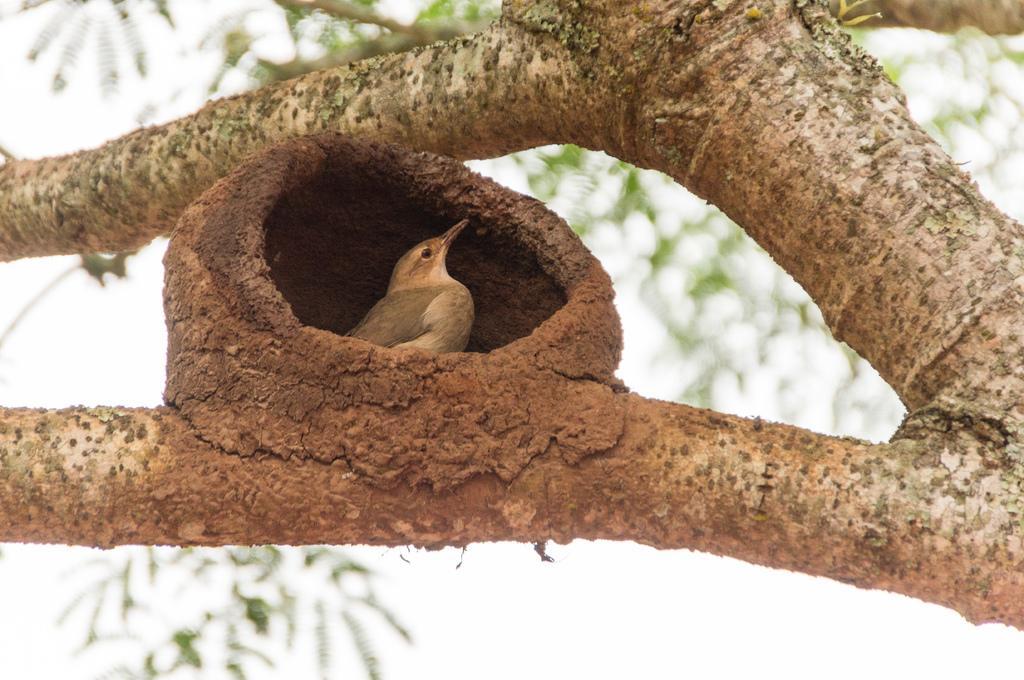Please provide a concise description of this image. In this picture we can see branches, a bird is present in a nest, leaves are present. In the background of the image sky is there. 